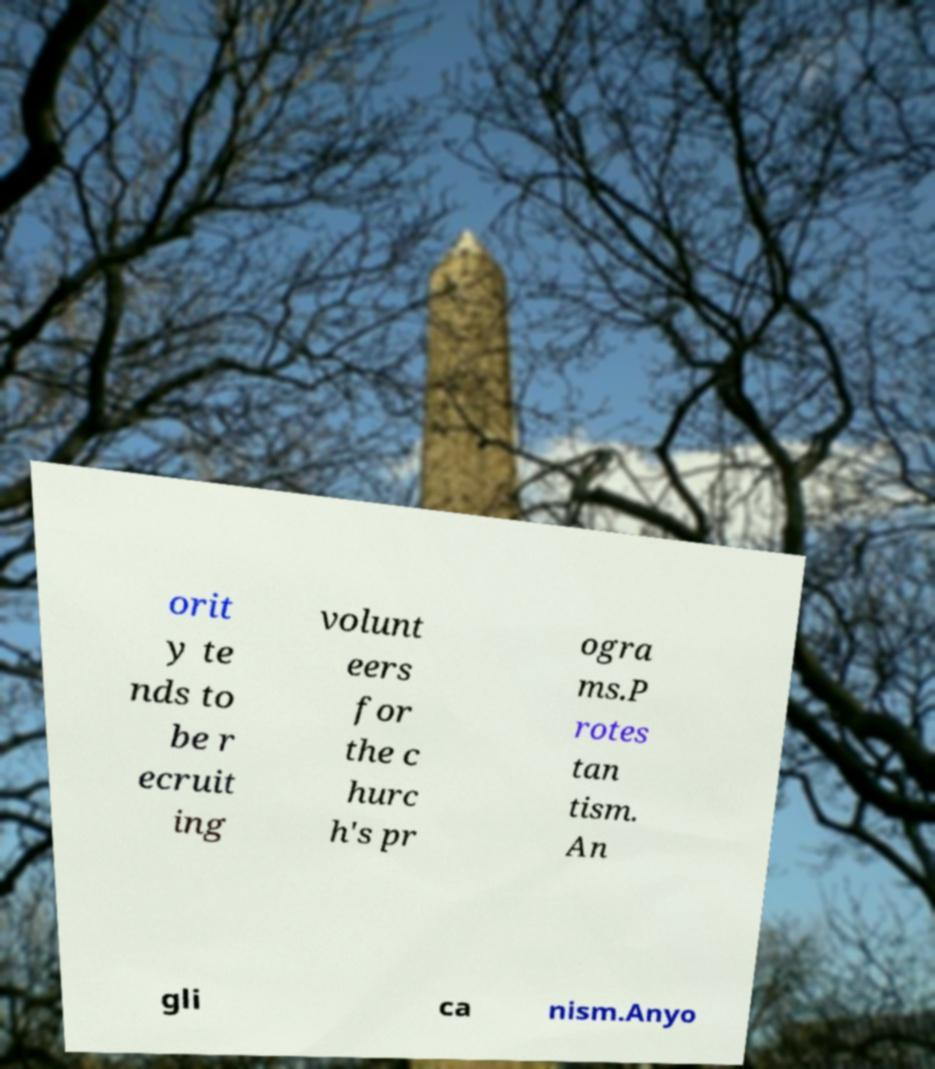Can you accurately transcribe the text from the provided image for me? orit y te nds to be r ecruit ing volunt eers for the c hurc h's pr ogra ms.P rotes tan tism. An gli ca nism.Anyo 